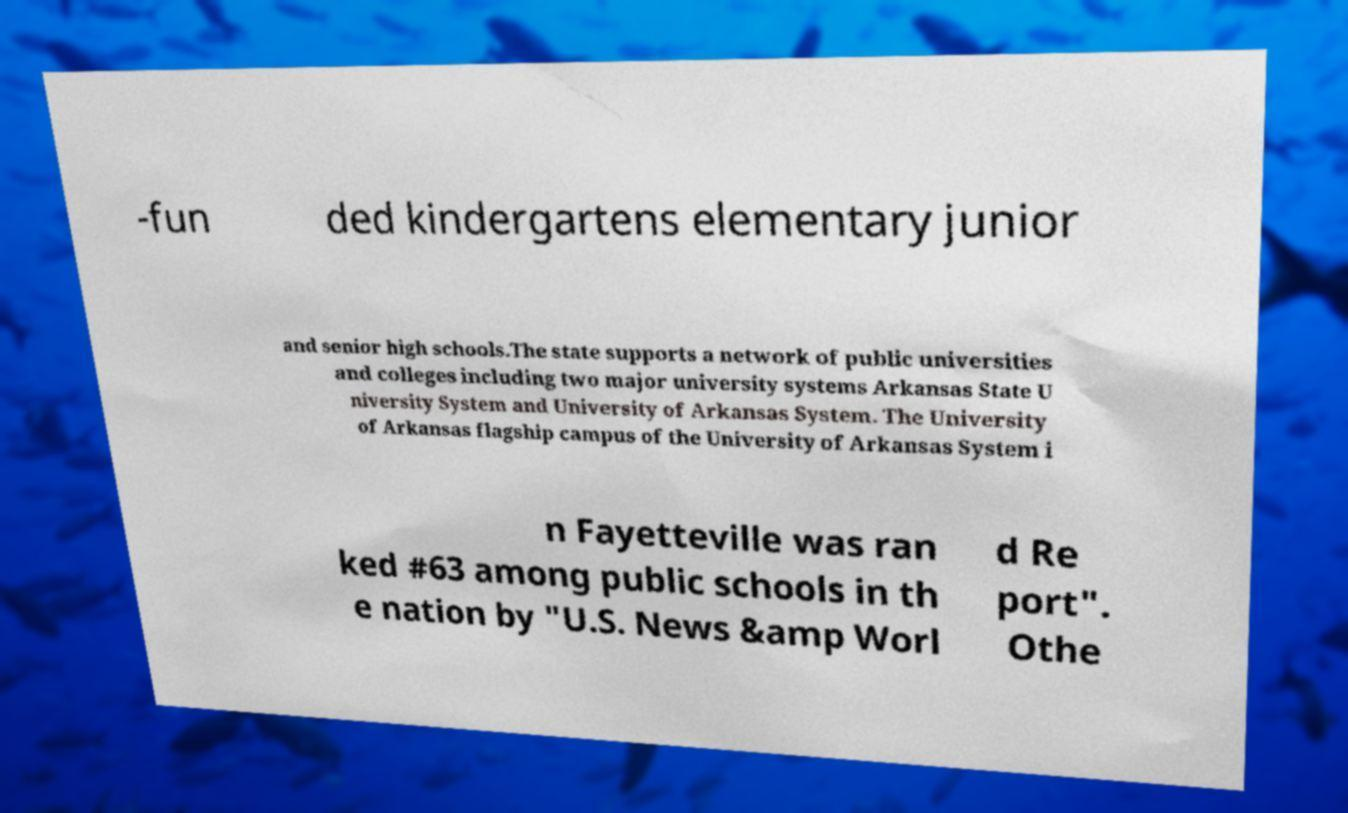Please read and relay the text visible in this image. What does it say? -fun ded kindergartens elementary junior and senior high schools.The state supports a network of public universities and colleges including two major university systems Arkansas State U niversity System and University of Arkansas System. The University of Arkansas flagship campus of the University of Arkansas System i n Fayetteville was ran ked #63 among public schools in th e nation by "U.S. News &amp Worl d Re port". Othe 